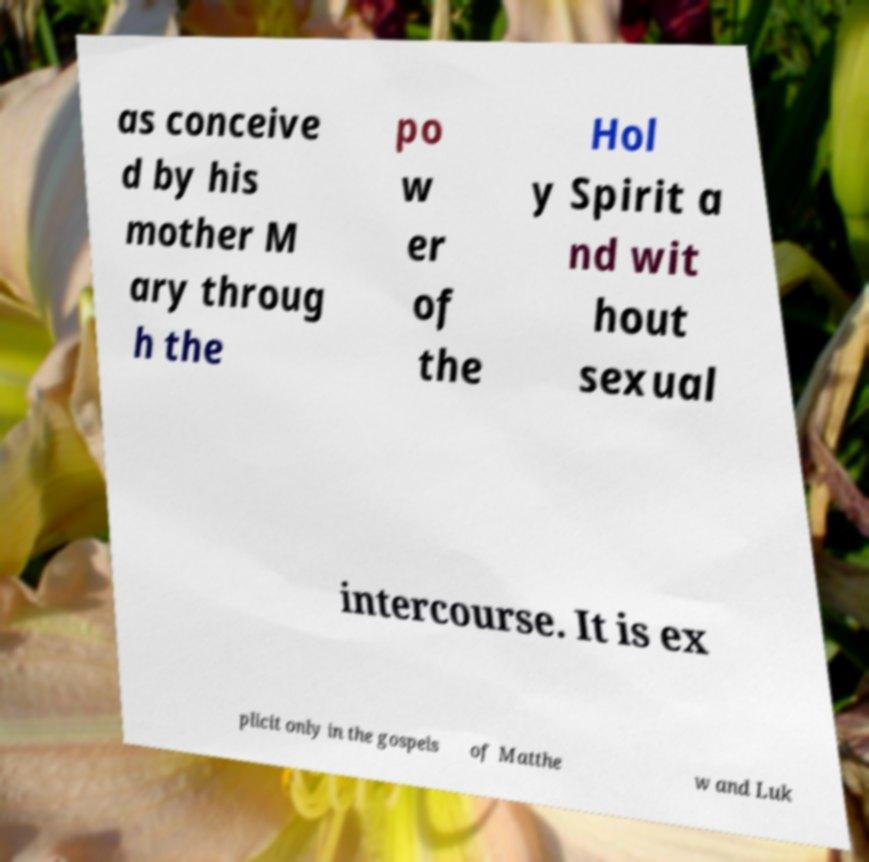Please identify and transcribe the text found in this image. as conceive d by his mother M ary throug h the po w er of the Hol y Spirit a nd wit hout sexual intercourse. It is ex plicit only in the gospels of Matthe w and Luk 